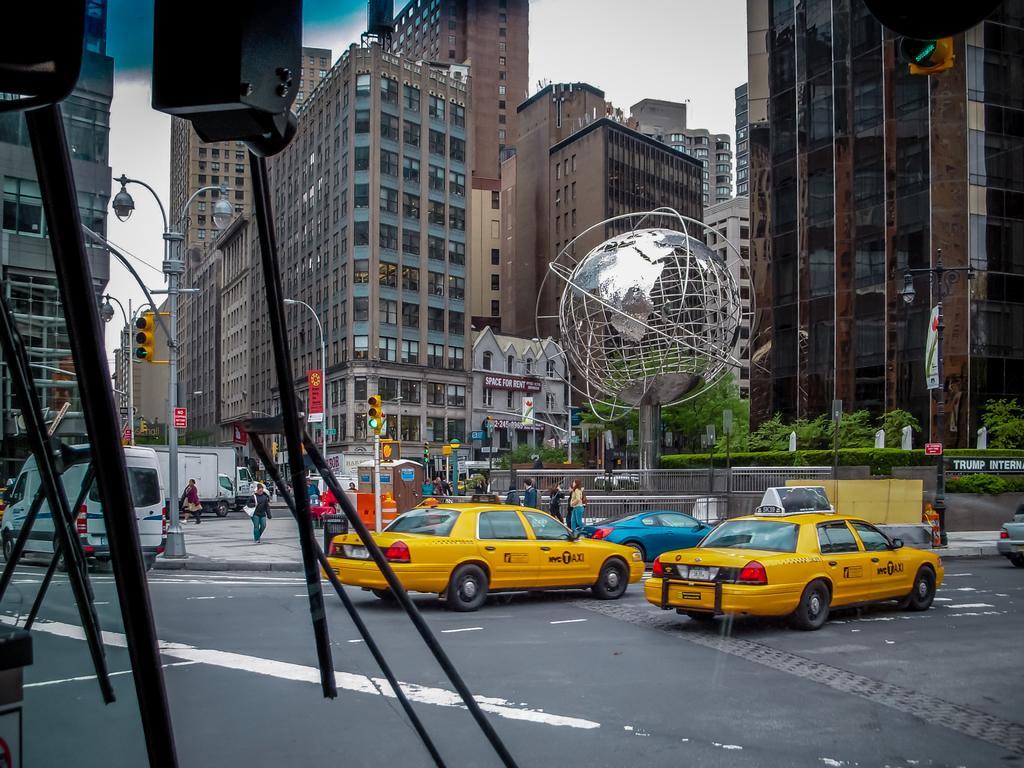How would you summarize this image in a sentence or two? These are the vehicles on the road. I can see the traffic signals attached to the poles. These are the buildings with the glass doors and the windows. This looks like a sculpture of the earth. There are few people standing. I think this is a street light. At the top of the image, that looks like an object, which is black in color. 